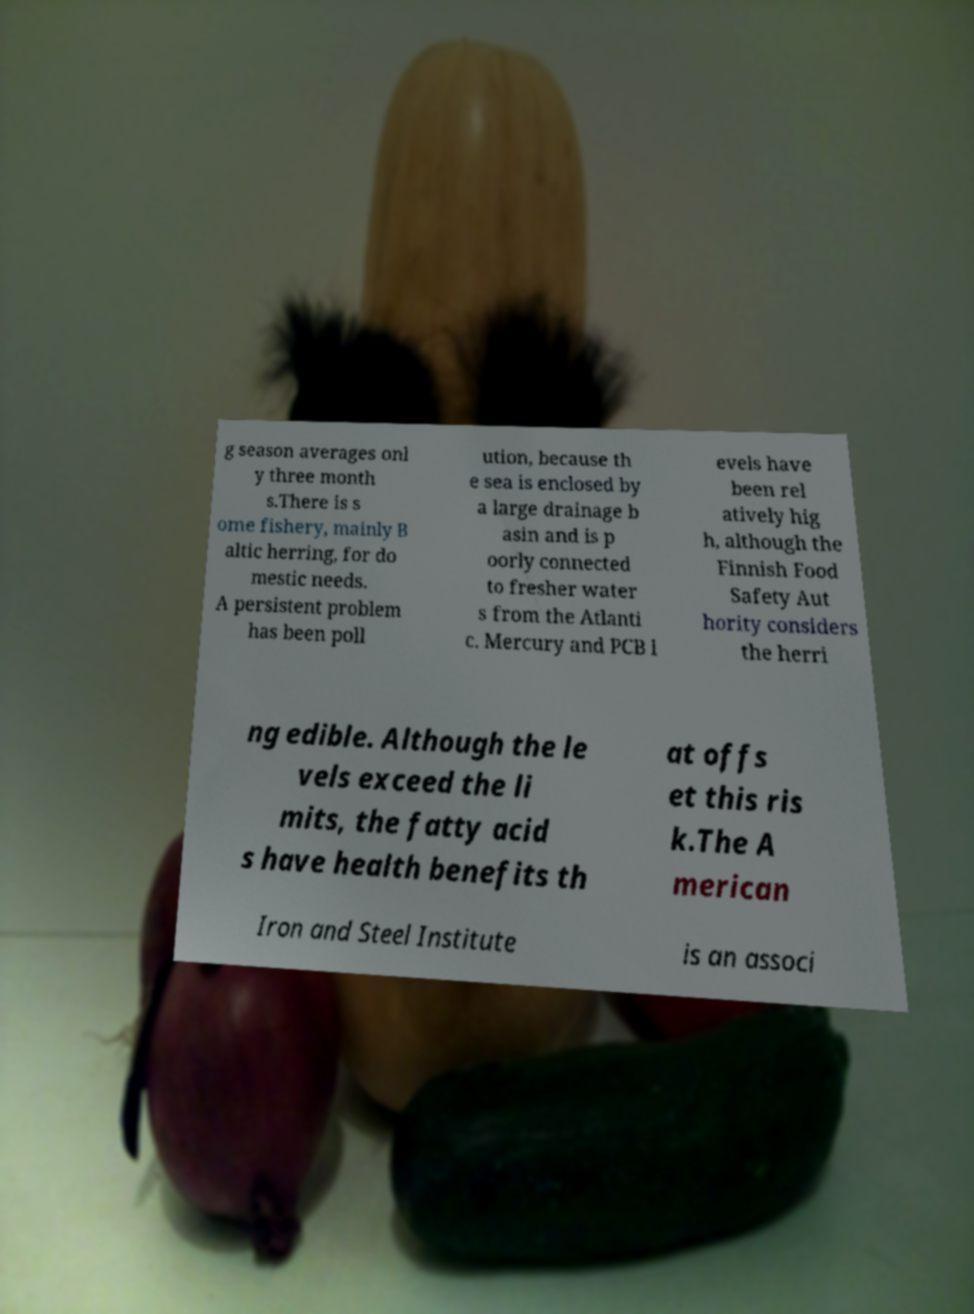Could you assist in decoding the text presented in this image and type it out clearly? g season averages onl y three month s.There is s ome fishery, mainly B altic herring, for do mestic needs. A persistent problem has been poll ution, because th e sea is enclosed by a large drainage b asin and is p oorly connected to fresher water s from the Atlanti c. Mercury and PCB l evels have been rel atively hig h, although the Finnish Food Safety Aut hority considers the herri ng edible. Although the le vels exceed the li mits, the fatty acid s have health benefits th at offs et this ris k.The A merican Iron and Steel Institute is an associ 